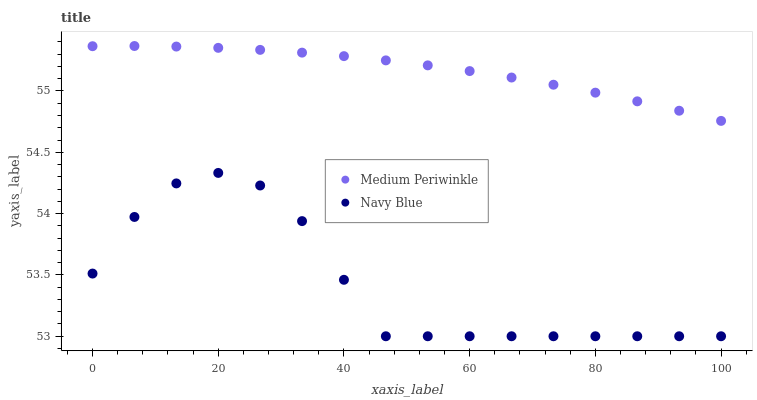Does Navy Blue have the minimum area under the curve?
Answer yes or no. Yes. Does Medium Periwinkle have the maximum area under the curve?
Answer yes or no. Yes. Does Medium Periwinkle have the minimum area under the curve?
Answer yes or no. No. Is Medium Periwinkle the smoothest?
Answer yes or no. Yes. Is Navy Blue the roughest?
Answer yes or no. Yes. Is Medium Periwinkle the roughest?
Answer yes or no. No. Does Navy Blue have the lowest value?
Answer yes or no. Yes. Does Medium Periwinkle have the lowest value?
Answer yes or no. No. Does Medium Periwinkle have the highest value?
Answer yes or no. Yes. Is Navy Blue less than Medium Periwinkle?
Answer yes or no. Yes. Is Medium Periwinkle greater than Navy Blue?
Answer yes or no. Yes. Does Navy Blue intersect Medium Periwinkle?
Answer yes or no. No. 